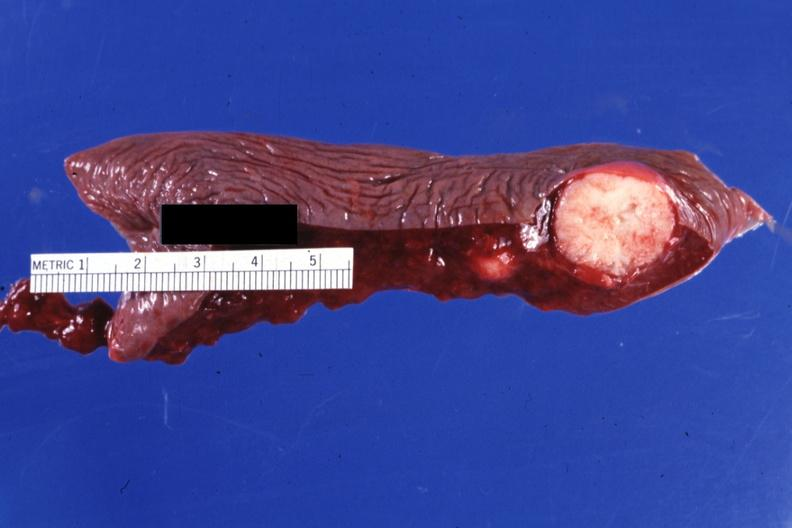s hematologic present?
Answer the question using a single word or phrase. Yes 